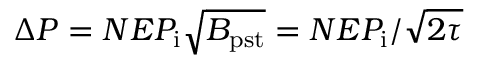<formula> <loc_0><loc_0><loc_500><loc_500>\Delta P = N E P _ { i } \sqrt { B _ { p s t } } = N E P _ { i } / \sqrt { 2 \tau }</formula> 